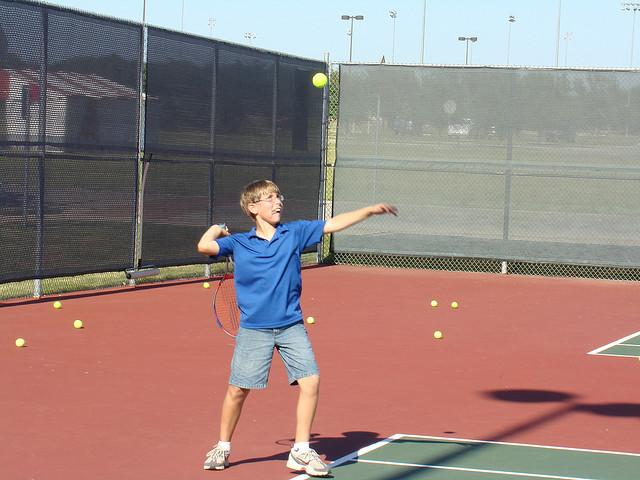What type of shot is the boy about to hit?

Choices:
A) backhand
B) slice
C) forehand
D) serve serve 